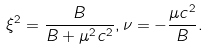<formula> <loc_0><loc_0><loc_500><loc_500>\xi ^ { 2 } = \frac { B } { B + \mu ^ { 2 } c ^ { 2 } } , \nu = - \frac { \mu c ^ { 2 } } { B } .</formula> 